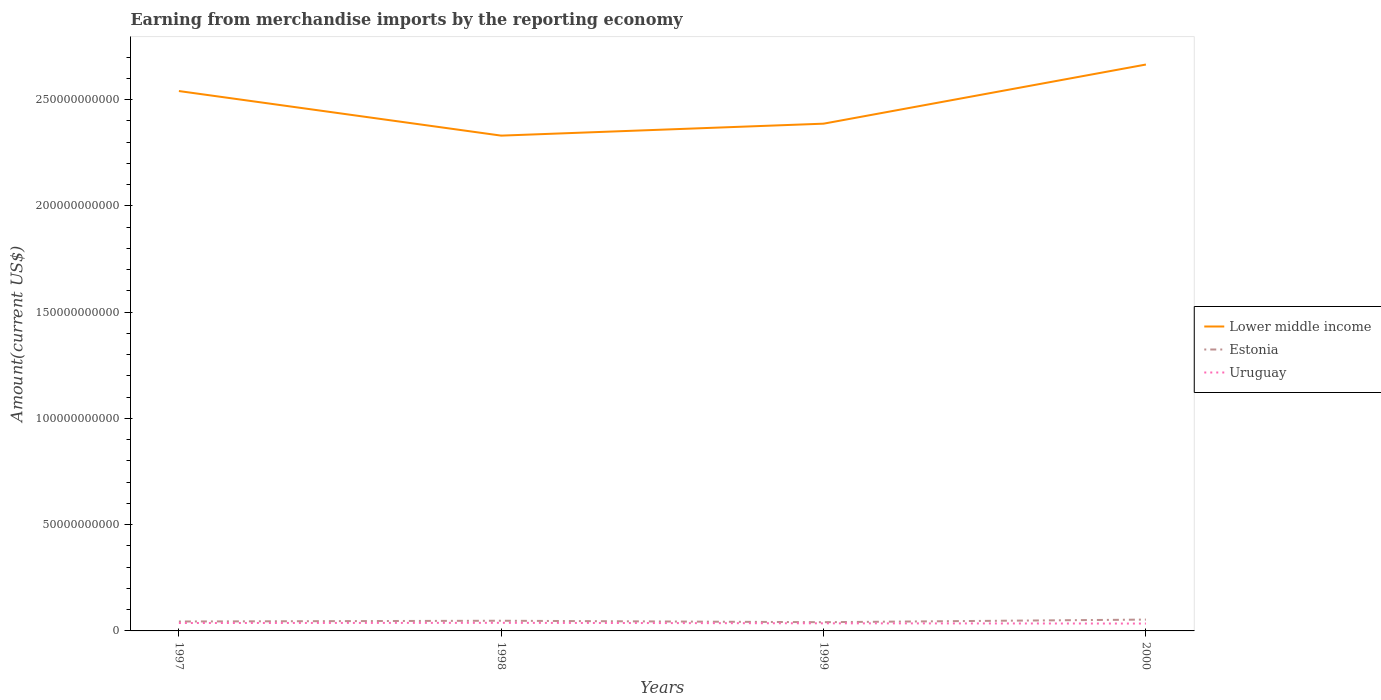Across all years, what is the maximum amount earned from merchandise imports in Lower middle income?
Provide a succinct answer. 2.33e+11. In which year was the amount earned from merchandise imports in Estonia maximum?
Your answer should be compact. 1999. What is the total amount earned from merchandise imports in Uruguay in the graph?
Ensure brevity in your answer.  1.37e+08. What is the difference between the highest and the second highest amount earned from merchandise imports in Uruguay?
Provide a succinct answer. 3.45e+08. What is the difference between the highest and the lowest amount earned from merchandise imports in Estonia?
Give a very brief answer. 2. Is the amount earned from merchandise imports in Uruguay strictly greater than the amount earned from merchandise imports in Lower middle income over the years?
Your response must be concise. Yes. How many lines are there?
Keep it short and to the point. 3. How many years are there in the graph?
Your answer should be very brief. 4. Are the values on the major ticks of Y-axis written in scientific E-notation?
Your answer should be compact. No. Does the graph contain any zero values?
Offer a very short reply. No. Does the graph contain grids?
Ensure brevity in your answer.  No. How many legend labels are there?
Provide a short and direct response. 3. What is the title of the graph?
Your answer should be very brief. Earning from merchandise imports by the reporting economy. Does "Gambia, The" appear as one of the legend labels in the graph?
Offer a very short reply. No. What is the label or title of the X-axis?
Provide a succinct answer. Years. What is the label or title of the Y-axis?
Provide a short and direct response. Amount(current US$). What is the Amount(current US$) of Lower middle income in 1997?
Make the answer very short. 2.54e+11. What is the Amount(current US$) of Estonia in 1997?
Give a very brief answer. 4.44e+09. What is the Amount(current US$) in Uruguay in 1997?
Provide a succinct answer. 3.72e+09. What is the Amount(current US$) of Lower middle income in 1998?
Your answer should be very brief. 2.33e+11. What is the Amount(current US$) in Estonia in 1998?
Your answer should be very brief. 4.79e+09. What is the Amount(current US$) in Uruguay in 1998?
Your response must be concise. 3.81e+09. What is the Amount(current US$) of Lower middle income in 1999?
Give a very brief answer. 2.39e+11. What is the Amount(current US$) of Estonia in 1999?
Offer a terse response. 4.11e+09. What is the Amount(current US$) of Uruguay in 1999?
Your response must be concise. 3.58e+09. What is the Amount(current US$) of Lower middle income in 2000?
Give a very brief answer. 2.67e+11. What is the Amount(current US$) of Estonia in 2000?
Your response must be concise. 5.33e+09. What is the Amount(current US$) in Uruguay in 2000?
Ensure brevity in your answer.  3.47e+09. Across all years, what is the maximum Amount(current US$) of Lower middle income?
Provide a short and direct response. 2.67e+11. Across all years, what is the maximum Amount(current US$) in Estonia?
Make the answer very short. 5.33e+09. Across all years, what is the maximum Amount(current US$) of Uruguay?
Provide a succinct answer. 3.81e+09. Across all years, what is the minimum Amount(current US$) in Lower middle income?
Provide a short and direct response. 2.33e+11. Across all years, what is the minimum Amount(current US$) of Estonia?
Keep it short and to the point. 4.11e+09. Across all years, what is the minimum Amount(current US$) in Uruguay?
Provide a short and direct response. 3.47e+09. What is the total Amount(current US$) of Lower middle income in the graph?
Your answer should be very brief. 9.92e+11. What is the total Amount(current US$) in Estonia in the graph?
Ensure brevity in your answer.  1.87e+1. What is the total Amount(current US$) in Uruguay in the graph?
Ensure brevity in your answer.  1.46e+1. What is the difference between the Amount(current US$) of Lower middle income in 1997 and that in 1998?
Your answer should be very brief. 2.10e+1. What is the difference between the Amount(current US$) in Estonia in 1997 and that in 1998?
Offer a very short reply. -3.50e+08. What is the difference between the Amount(current US$) of Uruguay in 1997 and that in 1998?
Ensure brevity in your answer.  -9.51e+07. What is the difference between the Amount(current US$) of Lower middle income in 1997 and that in 1999?
Give a very brief answer. 1.54e+1. What is the difference between the Amount(current US$) of Estonia in 1997 and that in 1999?
Keep it short and to the point. 3.27e+08. What is the difference between the Amount(current US$) of Uruguay in 1997 and that in 1999?
Your answer should be compact. 1.37e+08. What is the difference between the Amount(current US$) of Lower middle income in 1997 and that in 2000?
Your response must be concise. -1.25e+1. What is the difference between the Amount(current US$) of Estonia in 1997 and that in 2000?
Provide a short and direct response. -8.97e+08. What is the difference between the Amount(current US$) in Uruguay in 1997 and that in 2000?
Keep it short and to the point. 2.50e+08. What is the difference between the Amount(current US$) of Lower middle income in 1998 and that in 1999?
Provide a succinct answer. -5.63e+09. What is the difference between the Amount(current US$) in Estonia in 1998 and that in 1999?
Offer a terse response. 6.77e+08. What is the difference between the Amount(current US$) of Uruguay in 1998 and that in 1999?
Make the answer very short. 2.32e+08. What is the difference between the Amount(current US$) in Lower middle income in 1998 and that in 2000?
Provide a succinct answer. -3.35e+1. What is the difference between the Amount(current US$) in Estonia in 1998 and that in 2000?
Provide a short and direct response. -5.46e+08. What is the difference between the Amount(current US$) of Uruguay in 1998 and that in 2000?
Ensure brevity in your answer.  3.45e+08. What is the difference between the Amount(current US$) of Lower middle income in 1999 and that in 2000?
Your response must be concise. -2.78e+1. What is the difference between the Amount(current US$) of Estonia in 1999 and that in 2000?
Your response must be concise. -1.22e+09. What is the difference between the Amount(current US$) of Uruguay in 1999 and that in 2000?
Provide a short and direct response. 1.13e+08. What is the difference between the Amount(current US$) of Lower middle income in 1997 and the Amount(current US$) of Estonia in 1998?
Ensure brevity in your answer.  2.49e+11. What is the difference between the Amount(current US$) in Lower middle income in 1997 and the Amount(current US$) in Uruguay in 1998?
Make the answer very short. 2.50e+11. What is the difference between the Amount(current US$) of Estonia in 1997 and the Amount(current US$) of Uruguay in 1998?
Keep it short and to the point. 6.26e+08. What is the difference between the Amount(current US$) of Lower middle income in 1997 and the Amount(current US$) of Estonia in 1999?
Make the answer very short. 2.50e+11. What is the difference between the Amount(current US$) in Lower middle income in 1997 and the Amount(current US$) in Uruguay in 1999?
Your answer should be very brief. 2.50e+11. What is the difference between the Amount(current US$) of Estonia in 1997 and the Amount(current US$) of Uruguay in 1999?
Keep it short and to the point. 8.58e+08. What is the difference between the Amount(current US$) of Lower middle income in 1997 and the Amount(current US$) of Estonia in 2000?
Provide a short and direct response. 2.49e+11. What is the difference between the Amount(current US$) of Lower middle income in 1997 and the Amount(current US$) of Uruguay in 2000?
Offer a terse response. 2.51e+11. What is the difference between the Amount(current US$) in Estonia in 1997 and the Amount(current US$) in Uruguay in 2000?
Your answer should be compact. 9.71e+08. What is the difference between the Amount(current US$) of Lower middle income in 1998 and the Amount(current US$) of Estonia in 1999?
Give a very brief answer. 2.29e+11. What is the difference between the Amount(current US$) of Lower middle income in 1998 and the Amount(current US$) of Uruguay in 1999?
Your response must be concise. 2.30e+11. What is the difference between the Amount(current US$) in Estonia in 1998 and the Amount(current US$) in Uruguay in 1999?
Offer a very short reply. 1.21e+09. What is the difference between the Amount(current US$) in Lower middle income in 1998 and the Amount(current US$) in Estonia in 2000?
Keep it short and to the point. 2.28e+11. What is the difference between the Amount(current US$) in Lower middle income in 1998 and the Amount(current US$) in Uruguay in 2000?
Keep it short and to the point. 2.30e+11. What is the difference between the Amount(current US$) of Estonia in 1998 and the Amount(current US$) of Uruguay in 2000?
Provide a succinct answer. 1.32e+09. What is the difference between the Amount(current US$) of Lower middle income in 1999 and the Amount(current US$) of Estonia in 2000?
Offer a terse response. 2.33e+11. What is the difference between the Amount(current US$) of Lower middle income in 1999 and the Amount(current US$) of Uruguay in 2000?
Keep it short and to the point. 2.35e+11. What is the difference between the Amount(current US$) in Estonia in 1999 and the Amount(current US$) in Uruguay in 2000?
Your answer should be compact. 6.44e+08. What is the average Amount(current US$) in Lower middle income per year?
Your response must be concise. 2.48e+11. What is the average Amount(current US$) of Estonia per year?
Make the answer very short. 4.67e+09. What is the average Amount(current US$) of Uruguay per year?
Provide a short and direct response. 3.64e+09. In the year 1997, what is the difference between the Amount(current US$) of Lower middle income and Amount(current US$) of Estonia?
Keep it short and to the point. 2.50e+11. In the year 1997, what is the difference between the Amount(current US$) in Lower middle income and Amount(current US$) in Uruguay?
Provide a succinct answer. 2.50e+11. In the year 1997, what is the difference between the Amount(current US$) of Estonia and Amount(current US$) of Uruguay?
Provide a short and direct response. 7.21e+08. In the year 1998, what is the difference between the Amount(current US$) of Lower middle income and Amount(current US$) of Estonia?
Ensure brevity in your answer.  2.28e+11. In the year 1998, what is the difference between the Amount(current US$) of Lower middle income and Amount(current US$) of Uruguay?
Your answer should be compact. 2.29e+11. In the year 1998, what is the difference between the Amount(current US$) in Estonia and Amount(current US$) in Uruguay?
Keep it short and to the point. 9.77e+08. In the year 1999, what is the difference between the Amount(current US$) in Lower middle income and Amount(current US$) in Estonia?
Your response must be concise. 2.35e+11. In the year 1999, what is the difference between the Amount(current US$) in Lower middle income and Amount(current US$) in Uruguay?
Offer a very short reply. 2.35e+11. In the year 1999, what is the difference between the Amount(current US$) of Estonia and Amount(current US$) of Uruguay?
Offer a very short reply. 5.31e+08. In the year 2000, what is the difference between the Amount(current US$) of Lower middle income and Amount(current US$) of Estonia?
Your response must be concise. 2.61e+11. In the year 2000, what is the difference between the Amount(current US$) of Lower middle income and Amount(current US$) of Uruguay?
Offer a terse response. 2.63e+11. In the year 2000, what is the difference between the Amount(current US$) in Estonia and Amount(current US$) in Uruguay?
Provide a short and direct response. 1.87e+09. What is the ratio of the Amount(current US$) in Lower middle income in 1997 to that in 1998?
Your answer should be compact. 1.09. What is the ratio of the Amount(current US$) of Estonia in 1997 to that in 1998?
Provide a succinct answer. 0.93. What is the ratio of the Amount(current US$) of Lower middle income in 1997 to that in 1999?
Ensure brevity in your answer.  1.06. What is the ratio of the Amount(current US$) in Estonia in 1997 to that in 1999?
Provide a short and direct response. 1.08. What is the ratio of the Amount(current US$) in Uruguay in 1997 to that in 1999?
Make the answer very short. 1.04. What is the ratio of the Amount(current US$) in Lower middle income in 1997 to that in 2000?
Make the answer very short. 0.95. What is the ratio of the Amount(current US$) of Estonia in 1997 to that in 2000?
Keep it short and to the point. 0.83. What is the ratio of the Amount(current US$) in Uruguay in 1997 to that in 2000?
Provide a succinct answer. 1.07. What is the ratio of the Amount(current US$) in Lower middle income in 1998 to that in 1999?
Ensure brevity in your answer.  0.98. What is the ratio of the Amount(current US$) in Estonia in 1998 to that in 1999?
Give a very brief answer. 1.16. What is the ratio of the Amount(current US$) of Uruguay in 1998 to that in 1999?
Provide a succinct answer. 1.06. What is the ratio of the Amount(current US$) in Lower middle income in 1998 to that in 2000?
Make the answer very short. 0.87. What is the ratio of the Amount(current US$) of Estonia in 1998 to that in 2000?
Your answer should be compact. 0.9. What is the ratio of the Amount(current US$) in Uruguay in 1998 to that in 2000?
Keep it short and to the point. 1.1. What is the ratio of the Amount(current US$) of Lower middle income in 1999 to that in 2000?
Your answer should be very brief. 0.9. What is the ratio of the Amount(current US$) of Estonia in 1999 to that in 2000?
Your response must be concise. 0.77. What is the ratio of the Amount(current US$) of Uruguay in 1999 to that in 2000?
Offer a very short reply. 1.03. What is the difference between the highest and the second highest Amount(current US$) in Lower middle income?
Your answer should be compact. 1.25e+1. What is the difference between the highest and the second highest Amount(current US$) of Estonia?
Make the answer very short. 5.46e+08. What is the difference between the highest and the second highest Amount(current US$) of Uruguay?
Keep it short and to the point. 9.51e+07. What is the difference between the highest and the lowest Amount(current US$) in Lower middle income?
Make the answer very short. 3.35e+1. What is the difference between the highest and the lowest Amount(current US$) in Estonia?
Your answer should be very brief. 1.22e+09. What is the difference between the highest and the lowest Amount(current US$) in Uruguay?
Provide a short and direct response. 3.45e+08. 